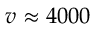<formula> <loc_0><loc_0><loc_500><loc_500>v \approx 4 0 0 0</formula> 